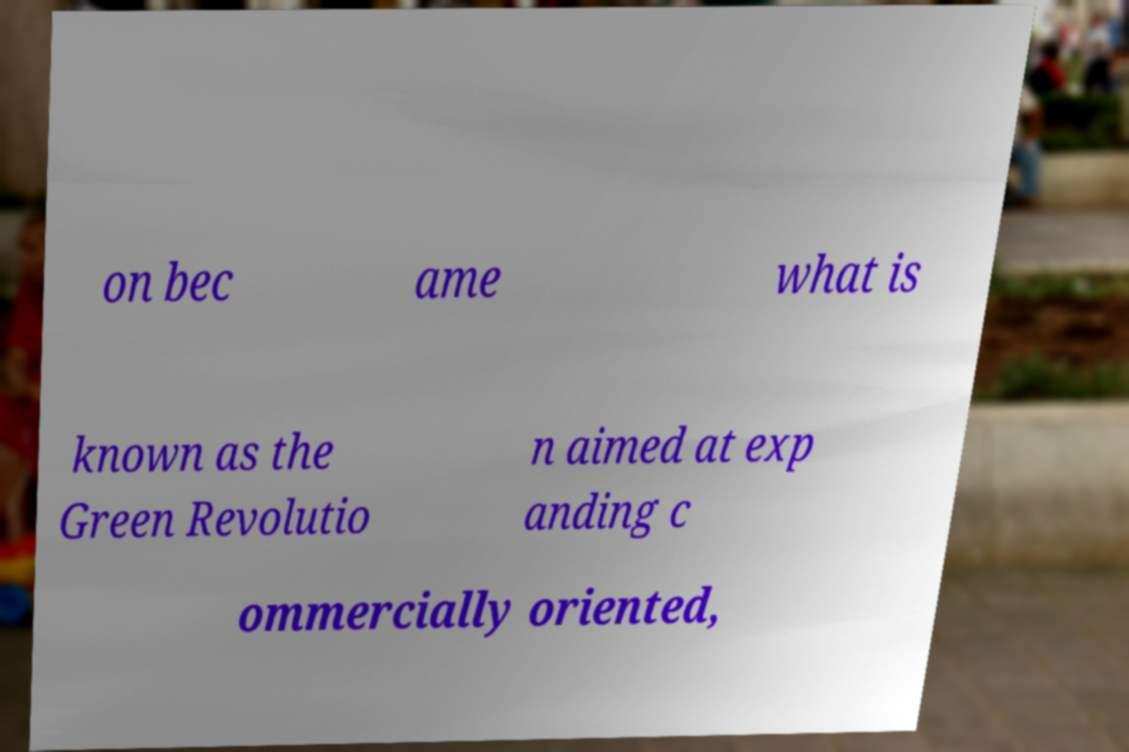Can you read and provide the text displayed in the image?This photo seems to have some interesting text. Can you extract and type it out for me? on bec ame what is known as the Green Revolutio n aimed at exp anding c ommercially oriented, 